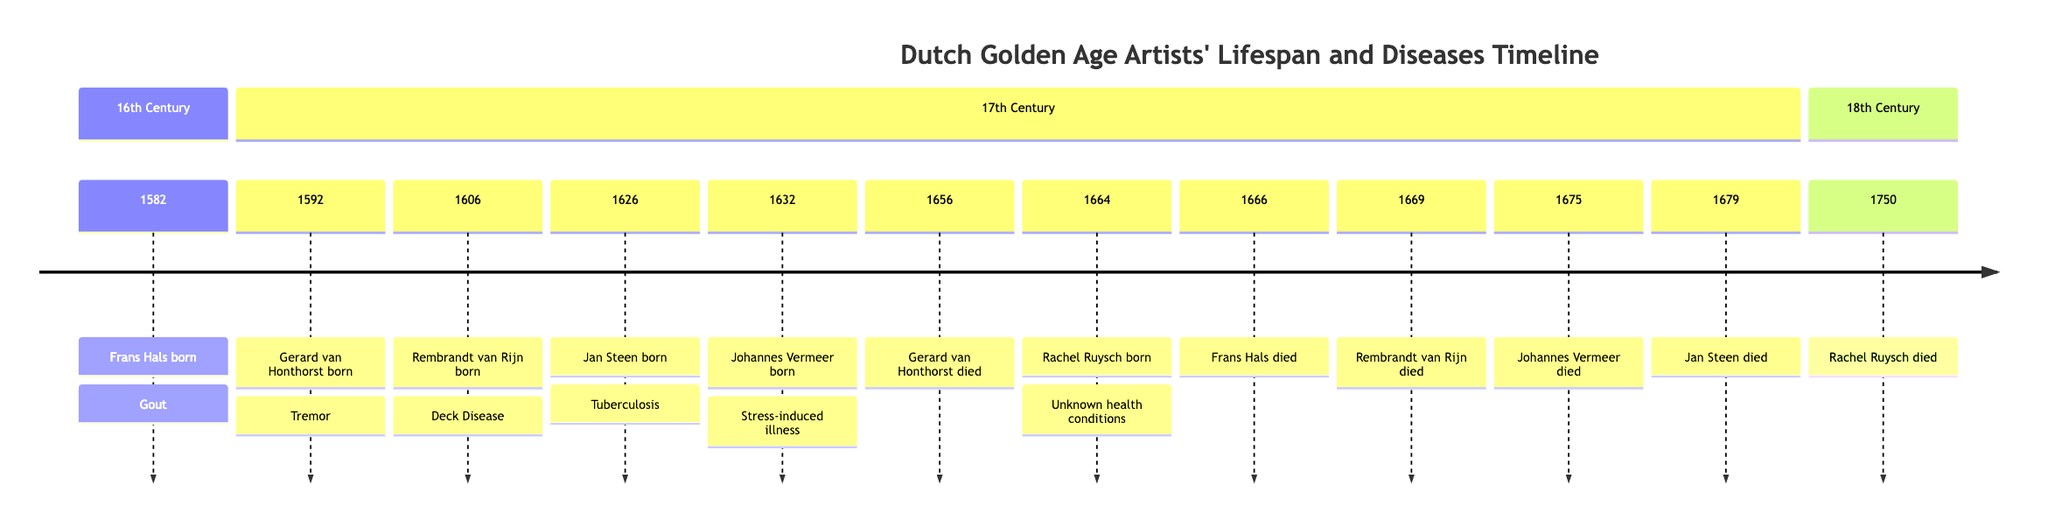What year was Gerhard van Honthorst born? The diagram indicates that Gerhard van Honthorst was born in the year 1592. This value is directly stated in the timeline section for the 17th Century.
Answer: 1592 How many artists are shown in the 17th Century section of the diagram? By counting the individual entries in the 17th Century section of the diagram, we notice there are five artists mentioned: Gerard van Honthorst, Rembrandt van Rijn, Jan Steen, Johannes Vermeer, and Frans Hals (noting also their birth years woven into the timeline).
Answer: 5 What significant health condition did Rembrandt van Rijn face? The diagram details that Rembrandt van Rijn faced deck disease. This information is conveyed directly next to his birth year in the 17th Century section.
Answer: Deck Disease Which artist died in the same year as Frans Hals? By reviewing the timeline, it shows that Frans Hals died in 1666, and upon checking the adjacent entries, it confirms that no other artists are noted to have died in that same year, making it unique to him.
Answer: None What was the disease associated with Jan Steen? The diagram specifies that Jan Steen suffered from tuberculosis, which is noted next to his birth year of 1626. This direct linkage allows us to clearly identify the health condition associated with him.
Answer: Tuberculosis Who was the last artist to die in the timeline? In the final section, it is seen that Rachel Ruysch died in 1750, which is the last entry in the 18th Century section of the timeline. Therefore, she is the last one listed before the timeline ends.
Answer: Rachel Ruysch Was Rachel Ruysch born before or after the death of Gerard van Honthorst? By referencing the respective entries, we find that Gerard van Honthorst died in 1656, and Rachel Ruysch was born in 1664. Since her birth year is later than his death year, we can conclude she was born after.
Answer: After What period did Johannes Vermeer die? Analyzing the diagram, we find the corresponding line shows that Johannes Vermeer died in the year 1675, which is clearly marked next to his name within the 17th Century section.
Answer: 1675 Name two artists from the timeline who faced health issues. The timeline mentions multiple artists with health conditions. For instance, Rembrandt van Rijn suffered from deck disease and Jan Steen faced tuberculosis, both of which are highlighted alongside their names.
Answer: Rembrandt van Rijn and Jan Steen 